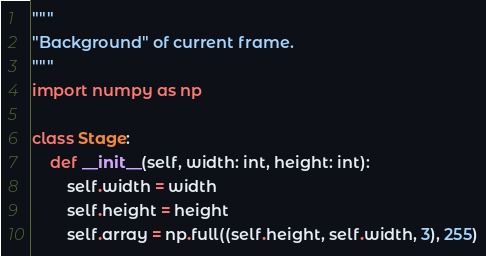Convert code to text. <code><loc_0><loc_0><loc_500><loc_500><_Python_>"""
"Background" of current frame.
"""
import numpy as np

class Stage:
    def __init__(self, width: int, height: int):
        self.width = width
        self.height = height
        self.array = np.full((self.height, self.width, 3), 255)</code> 